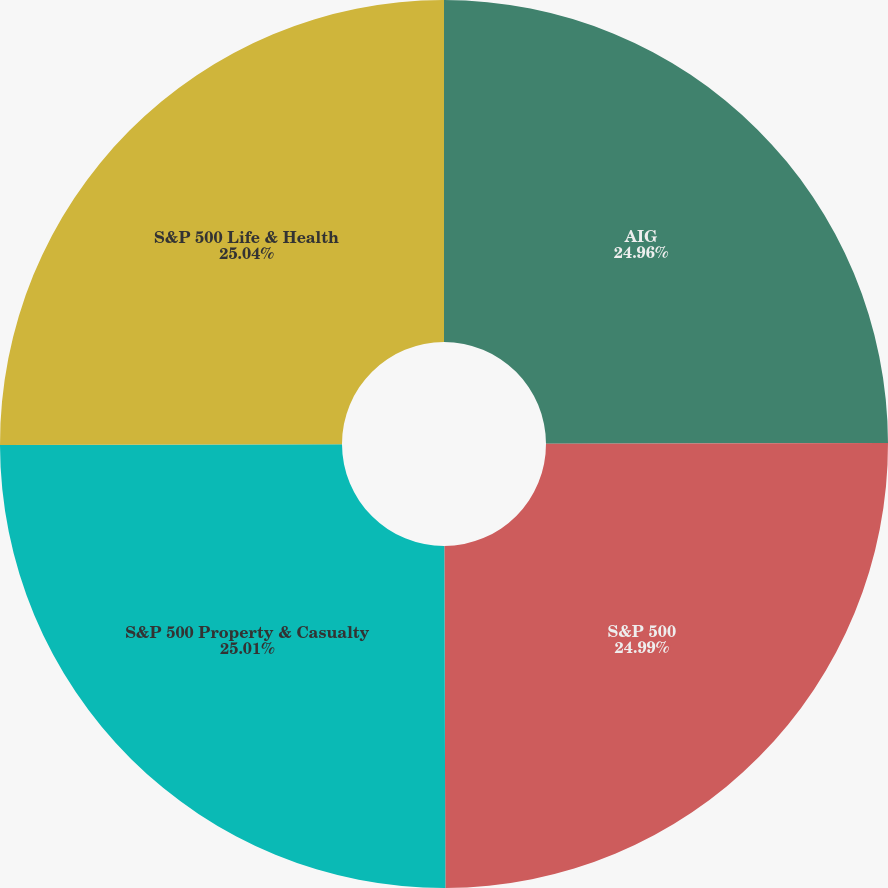Convert chart. <chart><loc_0><loc_0><loc_500><loc_500><pie_chart><fcel>AIG<fcel>S&P 500<fcel>S&P 500 Property & Casualty<fcel>S&P 500 Life & Health<nl><fcel>24.96%<fcel>24.99%<fcel>25.01%<fcel>25.04%<nl></chart> 